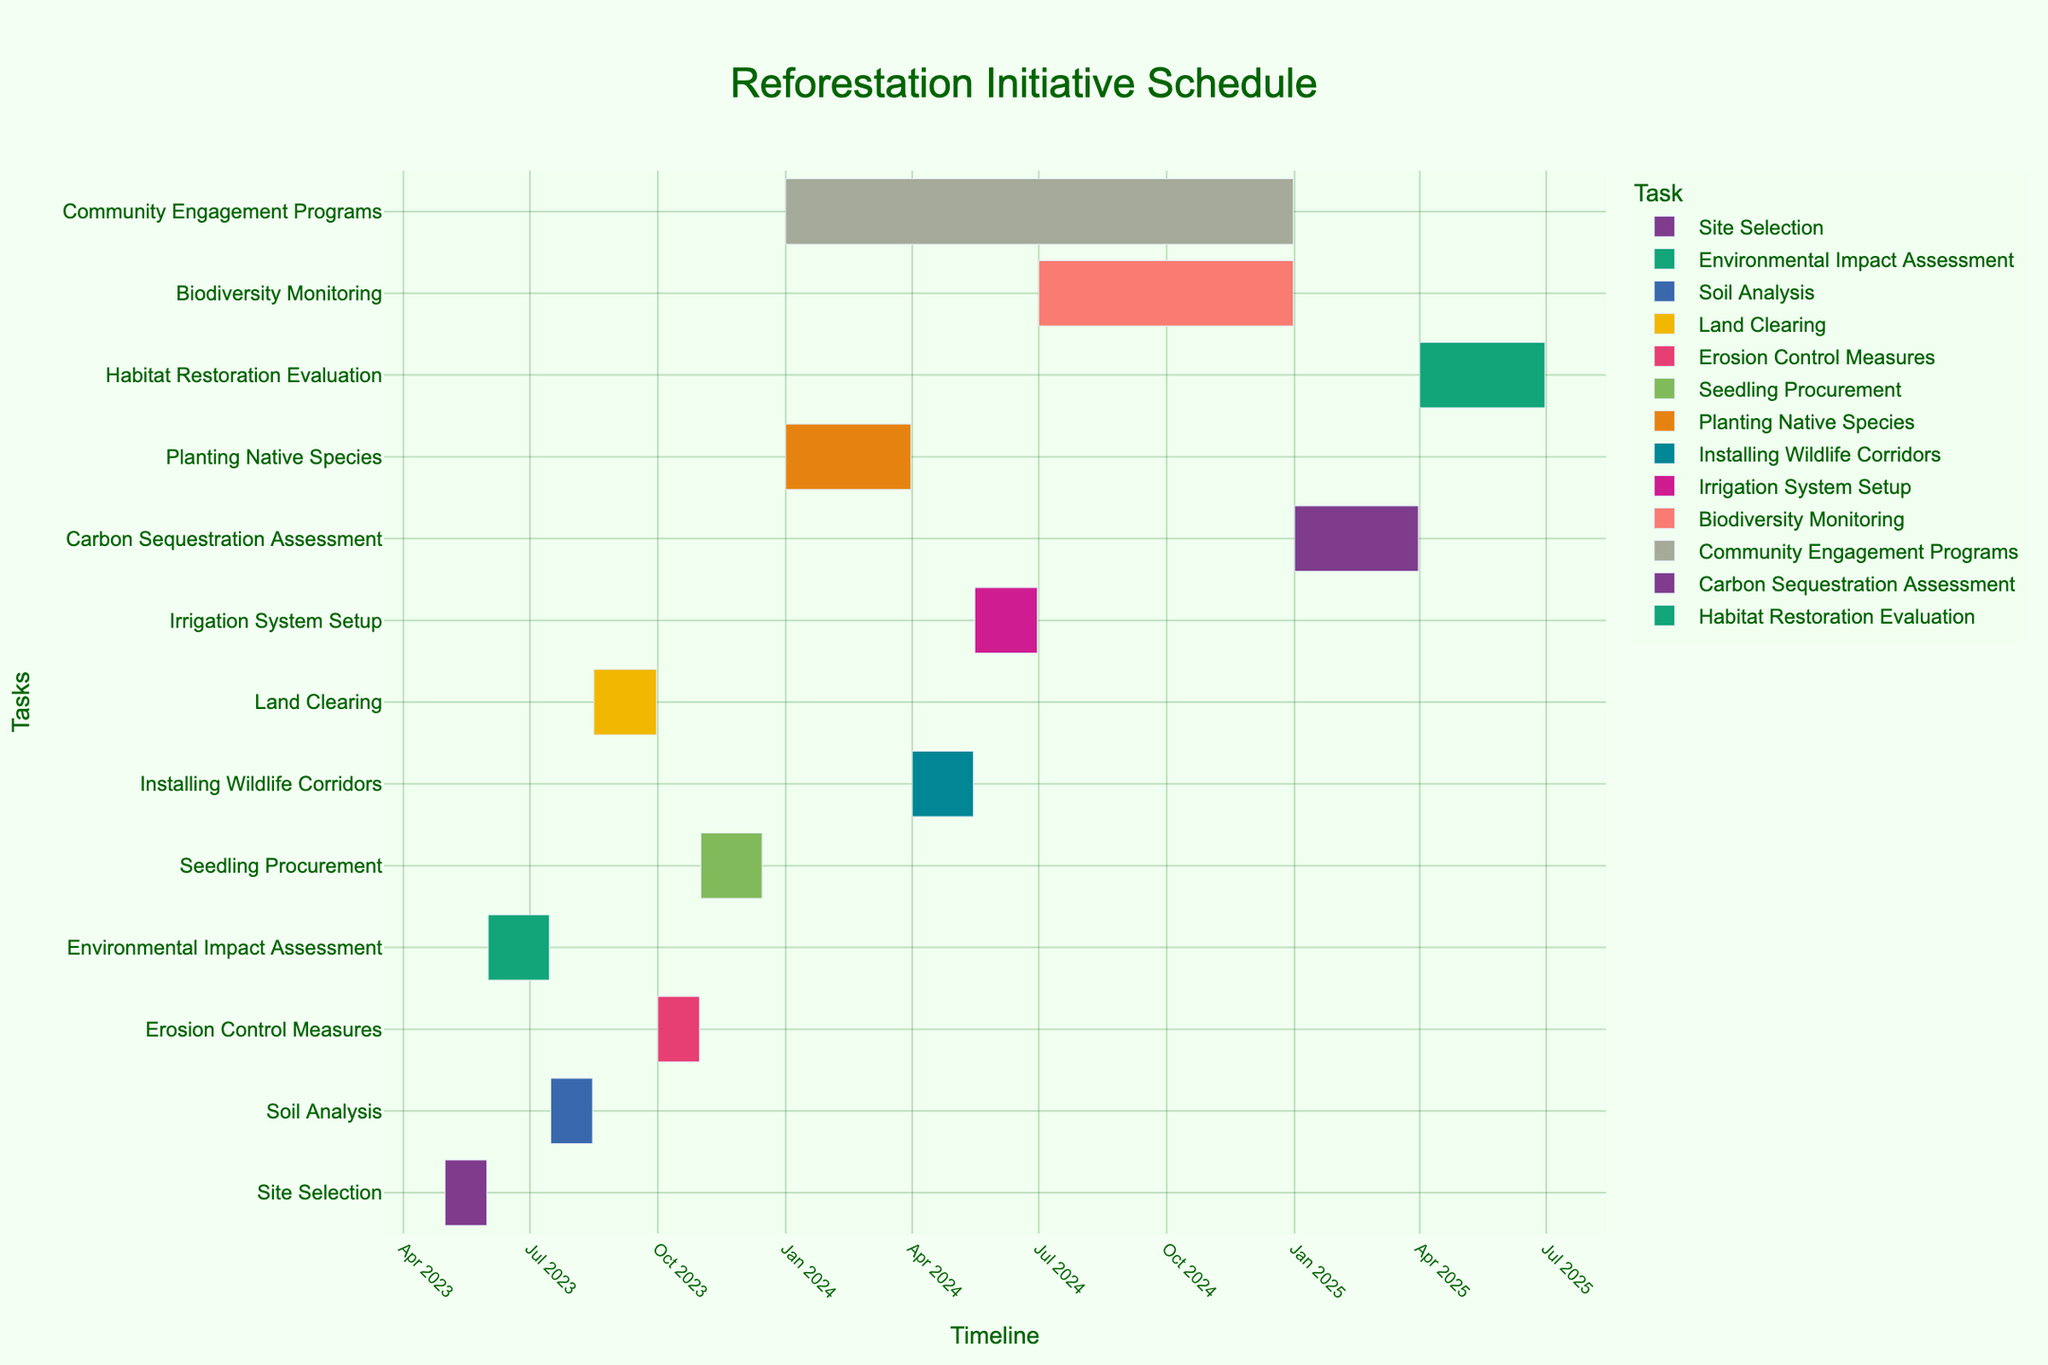What's the overall title of the Gantt chart? The overall title of the Gantt chart is displayed at the top of the chart. By reading it, one can understand the primary topic of the chart.
Answer: Reforestation Initiative Schedule What is the task that starts the earliest on the chart? By looking at the starting dates in the Gantt chart, the task that begins the earliest can be identified. It is located at the top of the list.
Answer: Site Selection How long does the Soil Analysis task take? To determine the duration of the Soil Analysis task, find the start and end dates for it, then compute the difference between these dates. Soil Analysis task starts on July 16, 2023, and ends on August 15, 2023.
Answer: 31 days Does any task span the entire year of 2024? By examining the start and end dates of tasks that fall within the year 2024, observe if any task spans from the beginning to the end of the year.
Answer: Community Engagement Programs Which phase ends just before Planting Native Species begins? Identify the start date of the Planting Native Species phase, then look for the phase that ends immediately before that date. The Planting Native Species phase begins on January 1, 2024, so find the task ending on or just before that date.
Answer: Seedling Procurement What tasks overlap with Installing Wildlife Corridors? Find the start and end dates of the Installing Wildlife Corridors task, and then check which other tasks have dates that overlap with these. The Installing Wildlife Corridors task runs from April 1, 2024, to May 15, 2024.
Answer: Community Engagement Programs, Irrigation System Setup Which task finishes last on the Gantt chart? By looking at the ending dates listed on the Gantt chart, identify the task that has the latest end date.
Answer: Habitat Restoration Evaluation How many tasks are scheduled after the year 2024? Count the number of tasks that have start or end dates falling in the year 2025.
Answer: 2 Which task has the longest duration? Calculate the duration of each task by finding the difference between the start and end dates, then identify the task with the longest span.
Answer: Community Engagement Programs What is the total number of tasks planned in the Gantt chart? Count the number of distinct tasks listed in the chart from start to end.
Answer: 13 